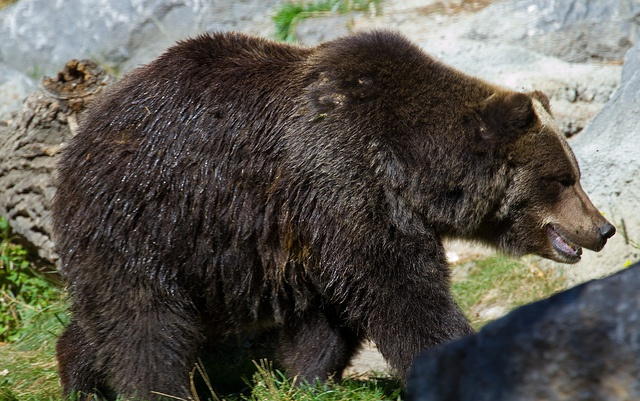Describe the objects in this image and their specific colors. I can see a bear in olive, black, and gray tones in this image. 